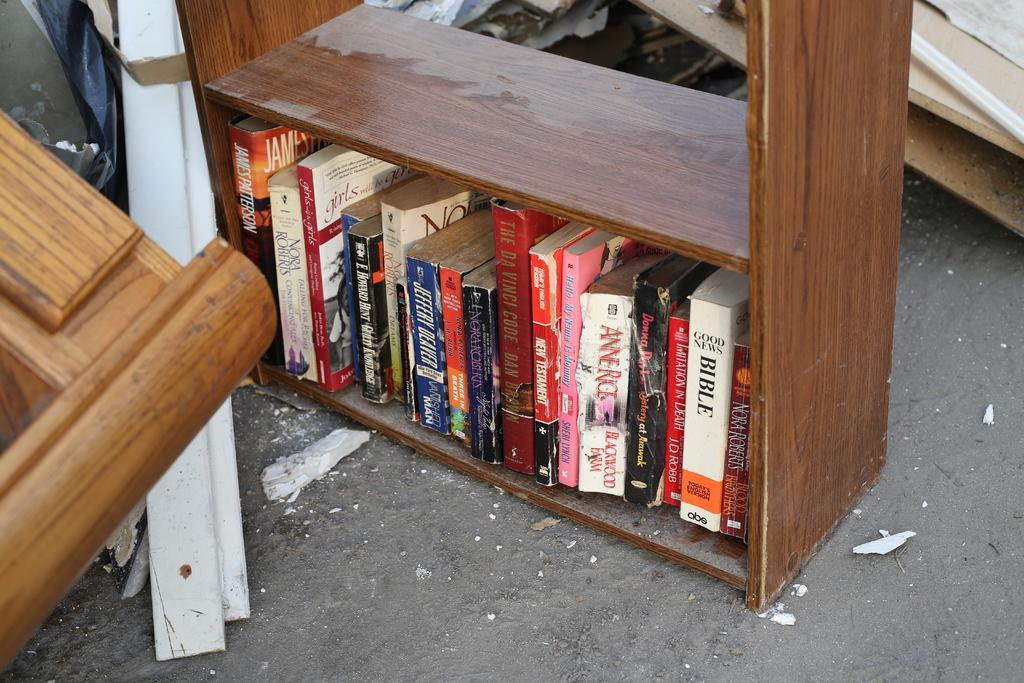Could you give a brief overview of what you see in this image? In this image we can see books in a shelf. There are other objects. At the bottom of the image there is road. 